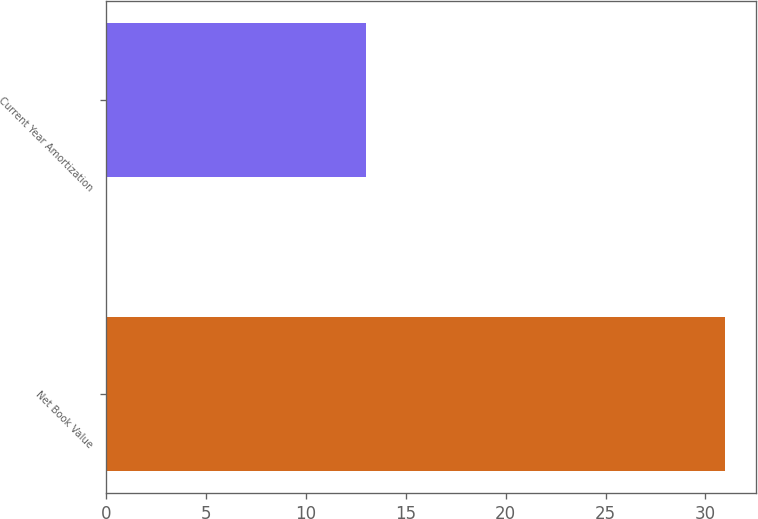Convert chart. <chart><loc_0><loc_0><loc_500><loc_500><bar_chart><fcel>Net Book Value<fcel>Current Year Amortization<nl><fcel>31<fcel>13<nl></chart> 